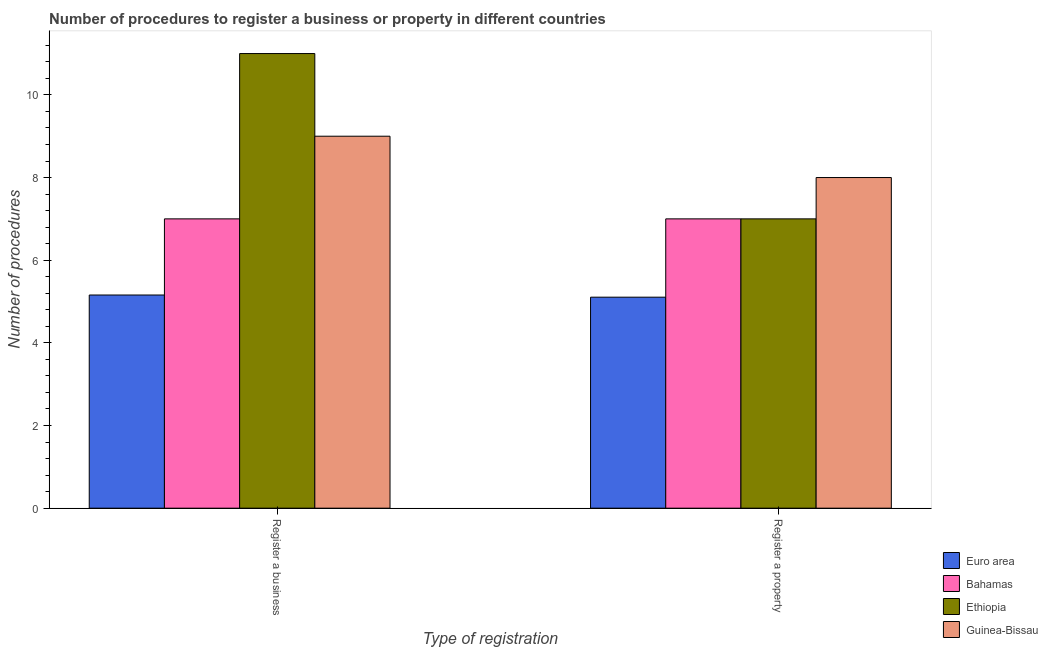How many different coloured bars are there?
Offer a terse response. 4. How many groups of bars are there?
Your response must be concise. 2. What is the label of the 2nd group of bars from the left?
Keep it short and to the point. Register a property. What is the number of procedures to register a property in Guinea-Bissau?
Your response must be concise. 8. Across all countries, what is the maximum number of procedures to register a business?
Your response must be concise. 11. Across all countries, what is the minimum number of procedures to register a business?
Your answer should be compact. 5.16. In which country was the number of procedures to register a property maximum?
Provide a short and direct response. Guinea-Bissau. In which country was the number of procedures to register a business minimum?
Give a very brief answer. Euro area. What is the total number of procedures to register a property in the graph?
Give a very brief answer. 27.11. What is the difference between the number of procedures to register a business in Ethiopia and that in Euro area?
Your answer should be very brief. 5.84. What is the difference between the number of procedures to register a business in Ethiopia and the number of procedures to register a property in Guinea-Bissau?
Offer a terse response. 3. What is the average number of procedures to register a property per country?
Offer a terse response. 6.78. What is the ratio of the number of procedures to register a business in Bahamas to that in Ethiopia?
Your response must be concise. 0.64. Is the number of procedures to register a business in Ethiopia less than that in Euro area?
Offer a very short reply. No. What does the 4th bar from the left in Register a property represents?
Keep it short and to the point. Guinea-Bissau. What does the 4th bar from the right in Register a business represents?
Your answer should be very brief. Euro area. How many bars are there?
Provide a short and direct response. 8. What is the difference between two consecutive major ticks on the Y-axis?
Offer a very short reply. 2. Does the graph contain any zero values?
Offer a very short reply. No. How many legend labels are there?
Offer a very short reply. 4. How are the legend labels stacked?
Provide a short and direct response. Vertical. What is the title of the graph?
Your answer should be very brief. Number of procedures to register a business or property in different countries. What is the label or title of the X-axis?
Make the answer very short. Type of registration. What is the label or title of the Y-axis?
Offer a terse response. Number of procedures. What is the Number of procedures of Euro area in Register a business?
Your response must be concise. 5.16. What is the Number of procedures of Guinea-Bissau in Register a business?
Ensure brevity in your answer.  9. What is the Number of procedures in Euro area in Register a property?
Make the answer very short. 5.11. What is the Number of procedures of Ethiopia in Register a property?
Offer a terse response. 7. What is the Number of procedures of Guinea-Bissau in Register a property?
Offer a very short reply. 8. Across all Type of registration, what is the maximum Number of procedures of Euro area?
Offer a terse response. 5.16. Across all Type of registration, what is the maximum Number of procedures in Ethiopia?
Ensure brevity in your answer.  11. Across all Type of registration, what is the minimum Number of procedures in Euro area?
Keep it short and to the point. 5.11. Across all Type of registration, what is the minimum Number of procedures in Ethiopia?
Ensure brevity in your answer.  7. What is the total Number of procedures of Euro area in the graph?
Your answer should be very brief. 10.26. What is the total Number of procedures in Bahamas in the graph?
Your answer should be very brief. 14. What is the total Number of procedures of Ethiopia in the graph?
Provide a short and direct response. 18. What is the difference between the Number of procedures of Euro area in Register a business and that in Register a property?
Give a very brief answer. 0.05. What is the difference between the Number of procedures in Guinea-Bissau in Register a business and that in Register a property?
Offer a terse response. 1. What is the difference between the Number of procedures in Euro area in Register a business and the Number of procedures in Bahamas in Register a property?
Ensure brevity in your answer.  -1.84. What is the difference between the Number of procedures of Euro area in Register a business and the Number of procedures of Ethiopia in Register a property?
Your answer should be very brief. -1.84. What is the difference between the Number of procedures in Euro area in Register a business and the Number of procedures in Guinea-Bissau in Register a property?
Your answer should be very brief. -2.84. What is the difference between the Number of procedures in Bahamas in Register a business and the Number of procedures in Ethiopia in Register a property?
Offer a very short reply. 0. What is the difference between the Number of procedures in Bahamas in Register a business and the Number of procedures in Guinea-Bissau in Register a property?
Keep it short and to the point. -1. What is the difference between the Number of procedures of Ethiopia in Register a business and the Number of procedures of Guinea-Bissau in Register a property?
Provide a short and direct response. 3. What is the average Number of procedures of Euro area per Type of registration?
Your answer should be very brief. 5.13. What is the average Number of procedures in Bahamas per Type of registration?
Your response must be concise. 7. What is the difference between the Number of procedures in Euro area and Number of procedures in Bahamas in Register a business?
Your response must be concise. -1.84. What is the difference between the Number of procedures of Euro area and Number of procedures of Ethiopia in Register a business?
Provide a succinct answer. -5.84. What is the difference between the Number of procedures of Euro area and Number of procedures of Guinea-Bissau in Register a business?
Provide a short and direct response. -3.84. What is the difference between the Number of procedures in Bahamas and Number of procedures in Ethiopia in Register a business?
Ensure brevity in your answer.  -4. What is the difference between the Number of procedures in Bahamas and Number of procedures in Guinea-Bissau in Register a business?
Your response must be concise. -2. What is the difference between the Number of procedures in Ethiopia and Number of procedures in Guinea-Bissau in Register a business?
Keep it short and to the point. 2. What is the difference between the Number of procedures of Euro area and Number of procedures of Bahamas in Register a property?
Provide a short and direct response. -1.89. What is the difference between the Number of procedures of Euro area and Number of procedures of Ethiopia in Register a property?
Offer a very short reply. -1.89. What is the difference between the Number of procedures of Euro area and Number of procedures of Guinea-Bissau in Register a property?
Offer a very short reply. -2.89. What is the difference between the Number of procedures of Bahamas and Number of procedures of Ethiopia in Register a property?
Your answer should be compact. 0. What is the difference between the Number of procedures of Ethiopia and Number of procedures of Guinea-Bissau in Register a property?
Your answer should be compact. -1. What is the ratio of the Number of procedures in Euro area in Register a business to that in Register a property?
Provide a short and direct response. 1.01. What is the ratio of the Number of procedures of Ethiopia in Register a business to that in Register a property?
Your answer should be compact. 1.57. What is the difference between the highest and the second highest Number of procedures of Euro area?
Make the answer very short. 0.05. What is the difference between the highest and the second highest Number of procedures of Bahamas?
Your answer should be very brief. 0. What is the difference between the highest and the second highest Number of procedures of Ethiopia?
Give a very brief answer. 4. What is the difference between the highest and the lowest Number of procedures in Euro area?
Provide a succinct answer. 0.05. What is the difference between the highest and the lowest Number of procedures in Bahamas?
Provide a succinct answer. 0. What is the difference between the highest and the lowest Number of procedures of Guinea-Bissau?
Your answer should be compact. 1. 